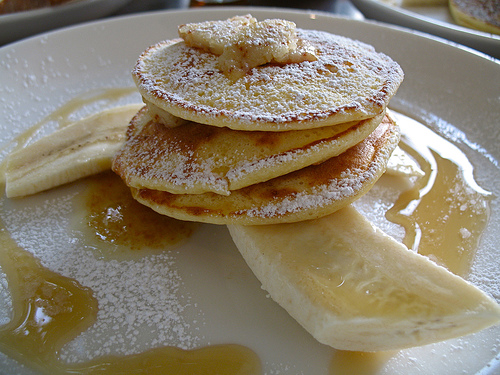<image>
Can you confirm if the powdered sugar is behind the banana? No. The powdered sugar is not behind the banana. From this viewpoint, the powdered sugar appears to be positioned elsewhere in the scene. Is the pancake above the banana? Yes. The pancake is positioned above the banana in the vertical space, higher up in the scene. 